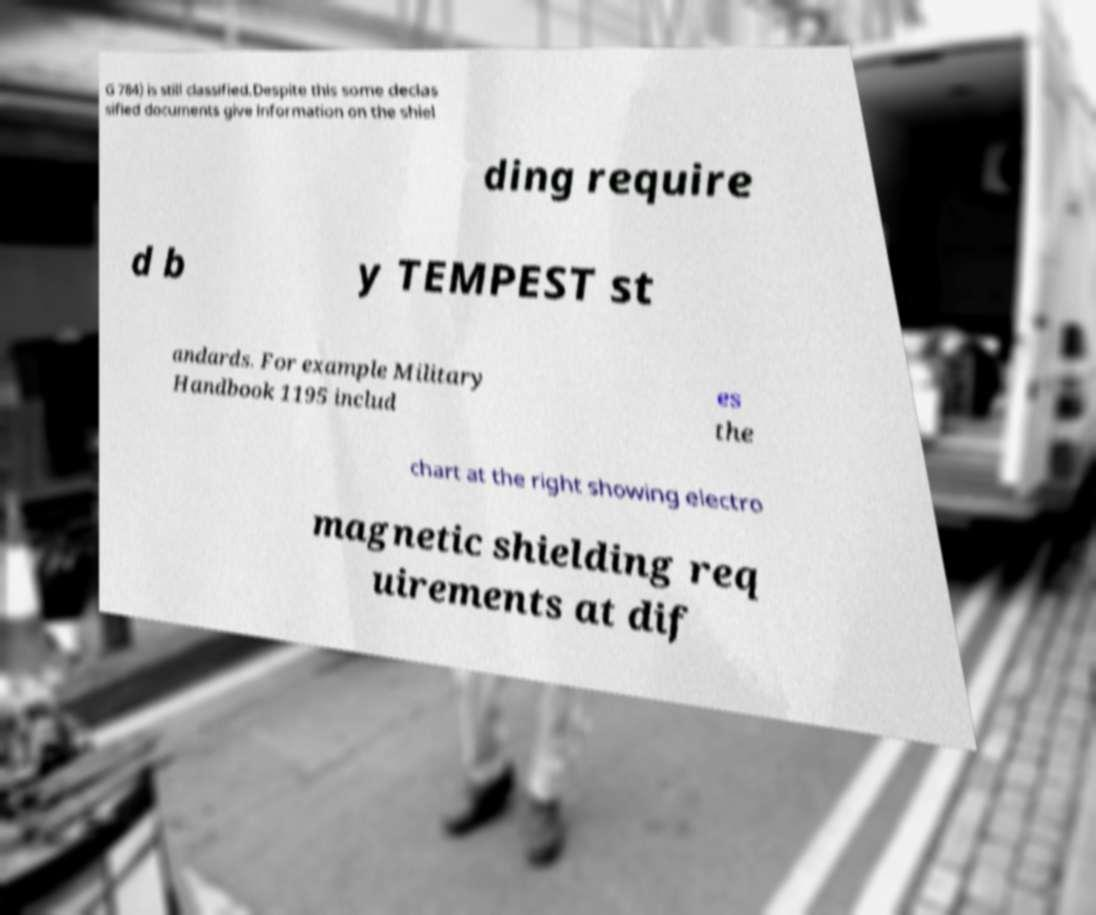Could you assist in decoding the text presented in this image and type it out clearly? G 784) is still classified.Despite this some declas sified documents give information on the shiel ding require d b y TEMPEST st andards. For example Military Handbook 1195 includ es the chart at the right showing electro magnetic shielding req uirements at dif 